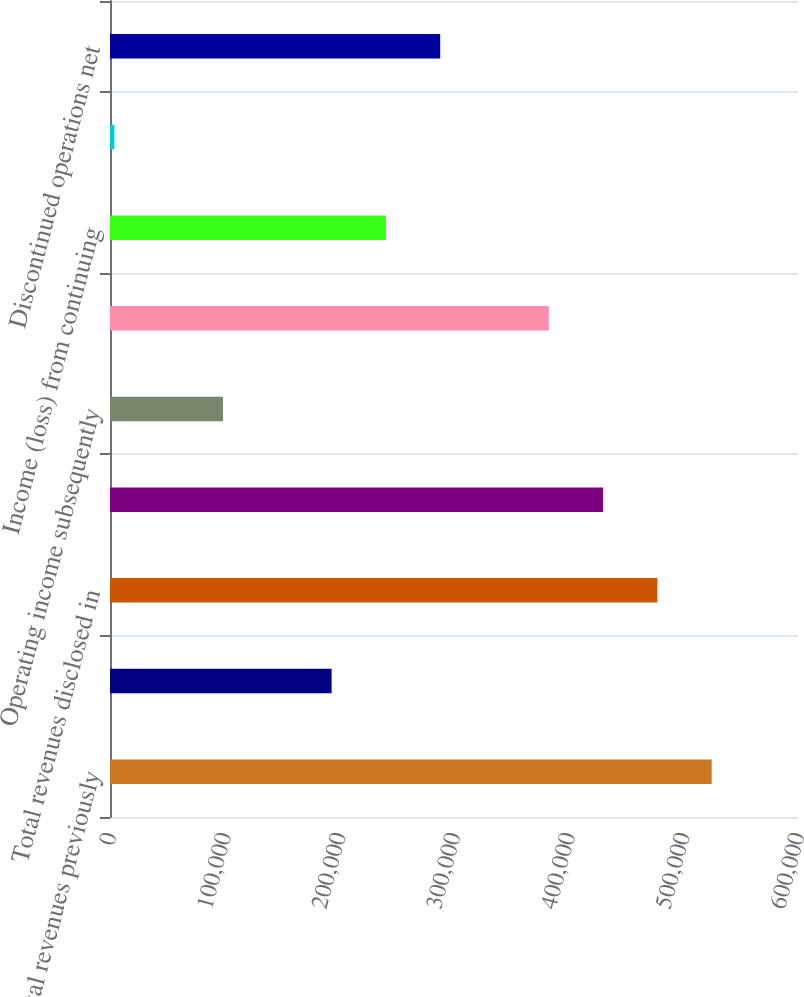<chart> <loc_0><loc_0><loc_500><loc_500><bar_chart><fcel>Total revenues previously<fcel>Total revenues subsequently<fcel>Total revenues disclosed in<fcel>Operating income previously<fcel>Operating income subsequently<fcel>Operating income disclosed in<fcel>Income (loss) from continuing<fcel>Income from continuing<fcel>Discontinued operations net<nl><fcel>524716<fcel>193256<fcel>477365<fcel>430014<fcel>98553<fcel>382662<fcel>240608<fcel>3850<fcel>287959<nl></chart> 